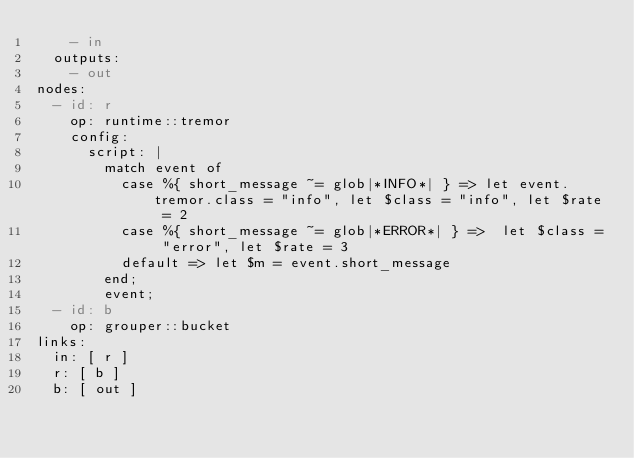Convert code to text. <code><loc_0><loc_0><loc_500><loc_500><_YAML_>    - in
  outputs:
    - out
nodes:
  - id: r
    op: runtime::tremor
    config:
      script: |
        match event of
          case %{ short_message ~= glob|*INFO*| } => let event.tremor.class = "info", let $class = "info", let $rate = 2
          case %{ short_message ~= glob|*ERROR*| } =>  let $class = "error", let $rate = 3
          default => let $m = event.short_message
        end;
        event;
  - id: b
    op: grouper::bucket
links:
  in: [ r ]
  r: [ b ]
  b: [ out ]</code> 